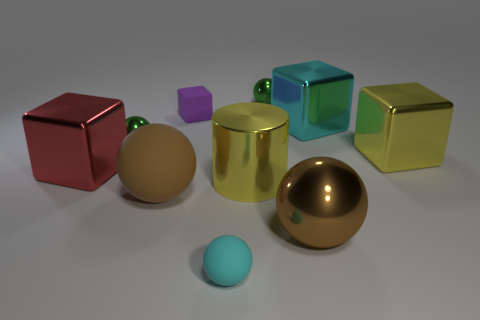How big is the brown object that is right of the tiny rubber sphere?
Provide a short and direct response. Large. What is the big yellow object to the right of the large cyan shiny thing made of?
Make the answer very short. Metal. How many yellow objects are either large blocks or shiny things?
Keep it short and to the point. 2. Do the big red cube and the cyan object that is behind the large red metal thing have the same material?
Make the answer very short. Yes. Are there the same number of tiny rubber balls that are behind the yellow metal cylinder and yellow cylinders that are behind the purple rubber object?
Give a very brief answer. Yes. There is a red metallic block; is it the same size as the brown thing that is left of the cyan sphere?
Ensure brevity in your answer.  Yes. Is the number of big metallic cylinders that are to the right of the cyan metallic thing greater than the number of small things?
Give a very brief answer. No. What number of matte blocks have the same size as the cyan sphere?
Provide a short and direct response. 1. There is a green metal sphere behind the small cube; does it have the same size as the yellow metal object to the right of the large cyan metal object?
Ensure brevity in your answer.  No. Is the number of brown matte objects that are right of the brown matte sphere greater than the number of cylinders behind the matte block?
Keep it short and to the point. No. 